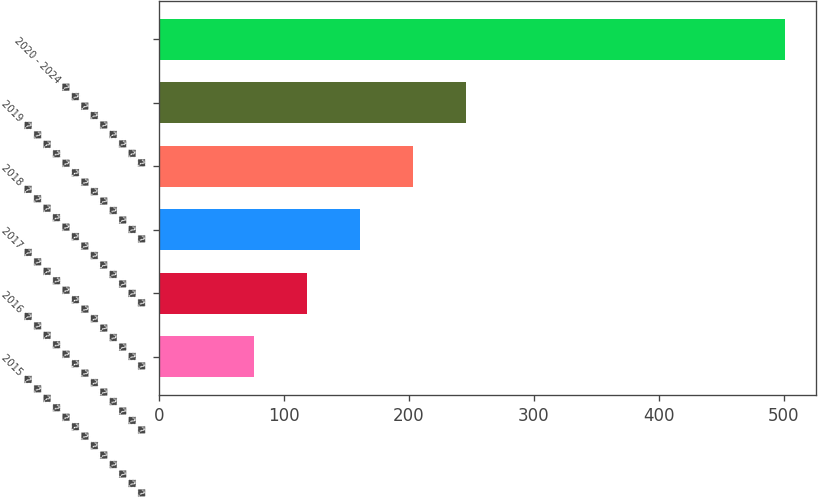<chart> <loc_0><loc_0><loc_500><loc_500><bar_chart><fcel>2015 � � � � � � � � � � � � �<fcel>2016 � � � � � � � � � � � � �<fcel>2017 � � � � � � � � � � � � �<fcel>2018 � � � � � � � � � � � � �<fcel>2019 � � � � � � � � � � � � �<fcel>2020 - 2024 � � � � � � � � �<nl><fcel>76<fcel>118.5<fcel>161<fcel>203.5<fcel>246<fcel>501<nl></chart> 